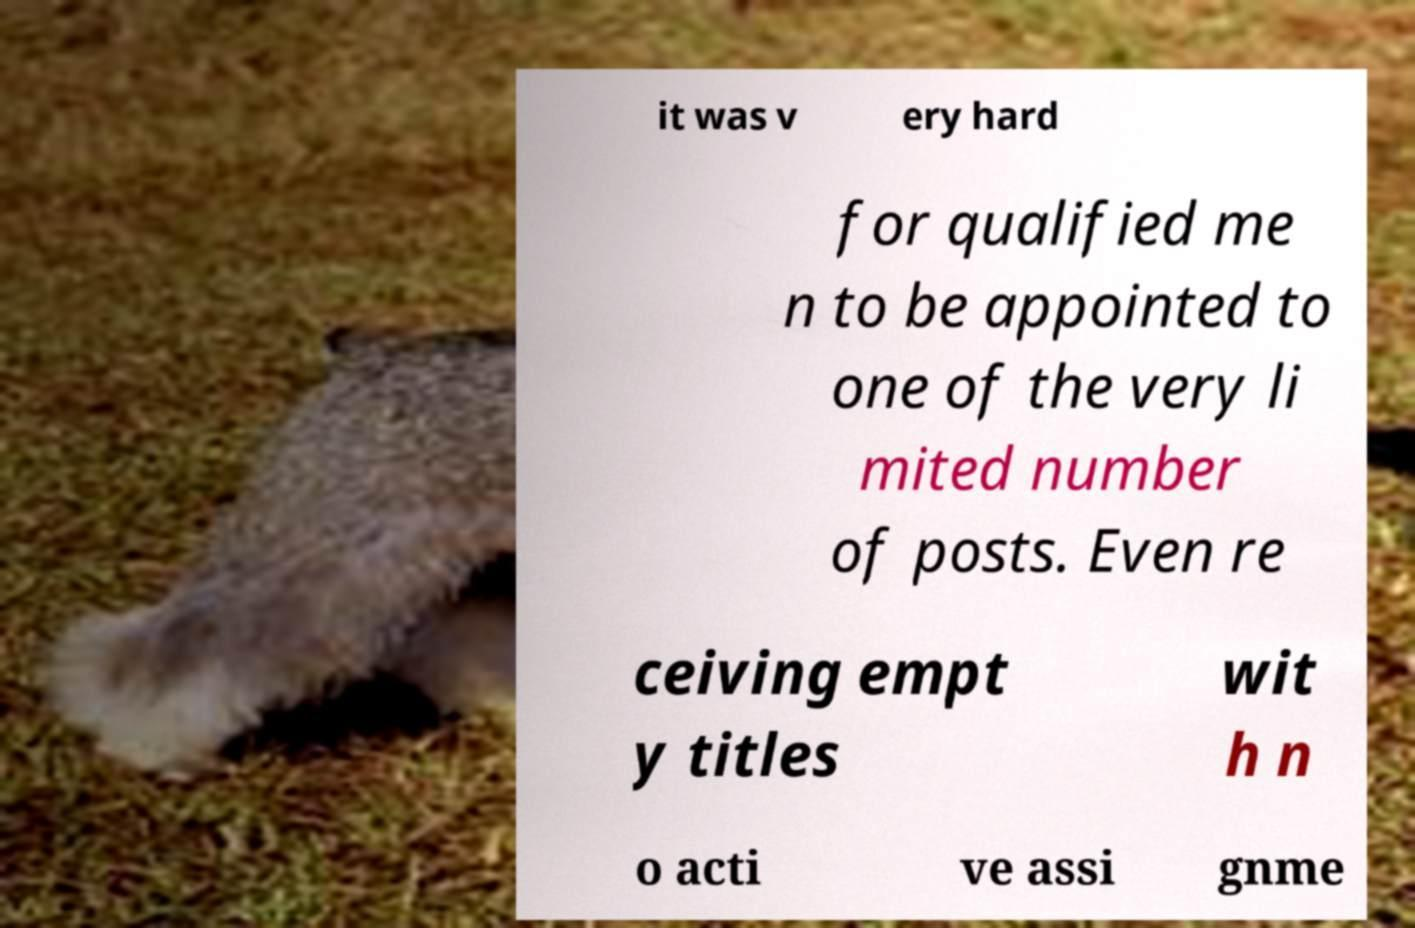Can you read and provide the text displayed in the image?This photo seems to have some interesting text. Can you extract and type it out for me? it was v ery hard for qualified me n to be appointed to one of the very li mited number of posts. Even re ceiving empt y titles wit h n o acti ve assi gnme 